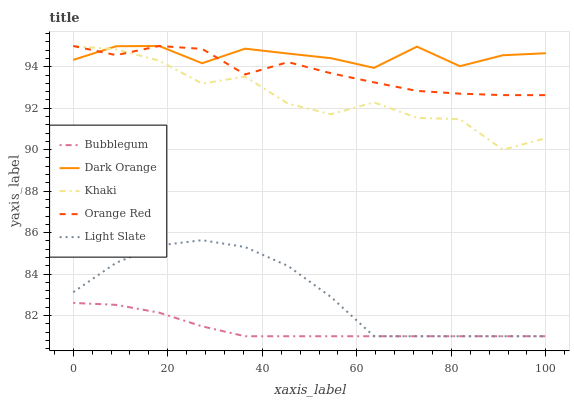Does Khaki have the minimum area under the curve?
Answer yes or no. No. Does Khaki have the maximum area under the curve?
Answer yes or no. No. Is Dark Orange the smoothest?
Answer yes or no. No. Is Dark Orange the roughest?
Answer yes or no. No. Does Khaki have the lowest value?
Answer yes or no. No. Does Bubblegum have the highest value?
Answer yes or no. No. Is Bubblegum less than Khaki?
Answer yes or no. Yes. Is Dark Orange greater than Light Slate?
Answer yes or no. Yes. Does Bubblegum intersect Khaki?
Answer yes or no. No. 